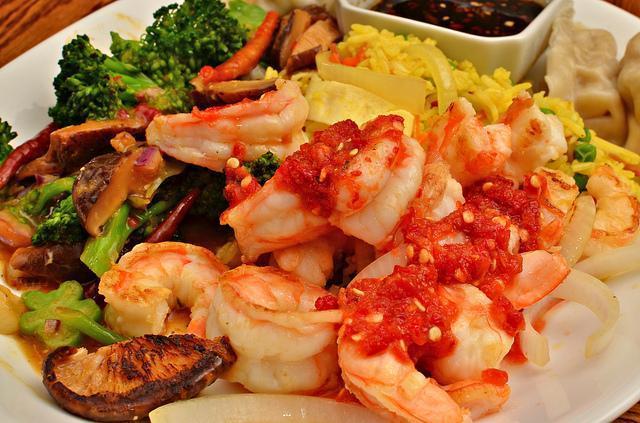How many broccolis are there?
Give a very brief answer. 3. How many girls are in midair?
Give a very brief answer. 0. 